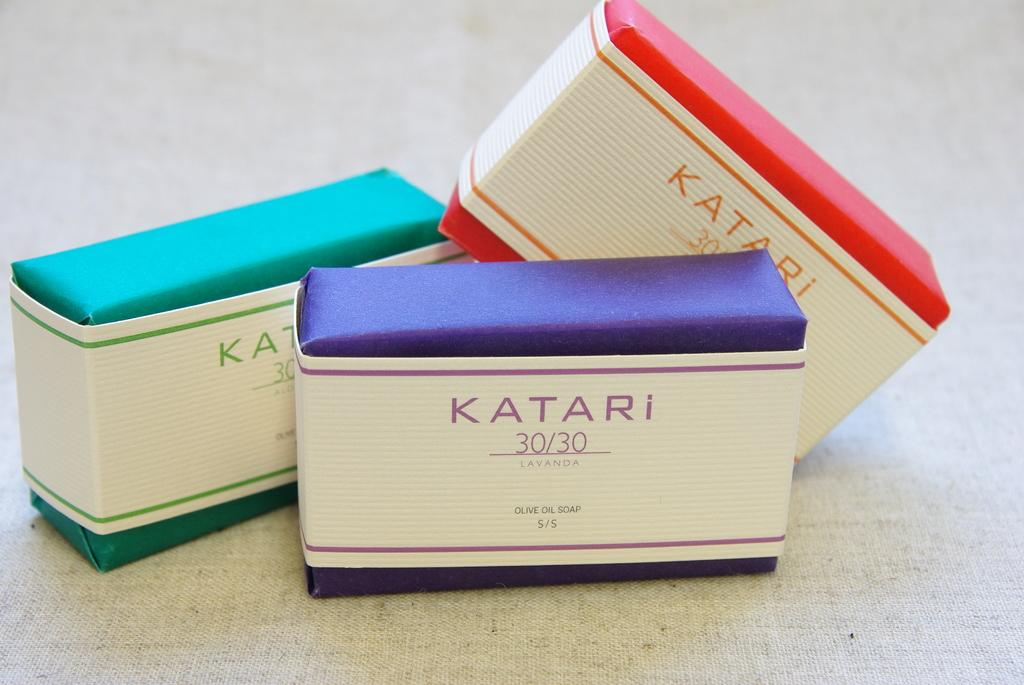What can be found in the center of the image? There are three different types of soaps in the center of the image. How many soaps are there in total? There are three soaps in the image. What is located at the bottom of the image? There is a cloth at the bottom of the image. What type of hearing aid is visible in the image? There is no hearing aid present in the image; it features three different types of soaps and a cloth. 